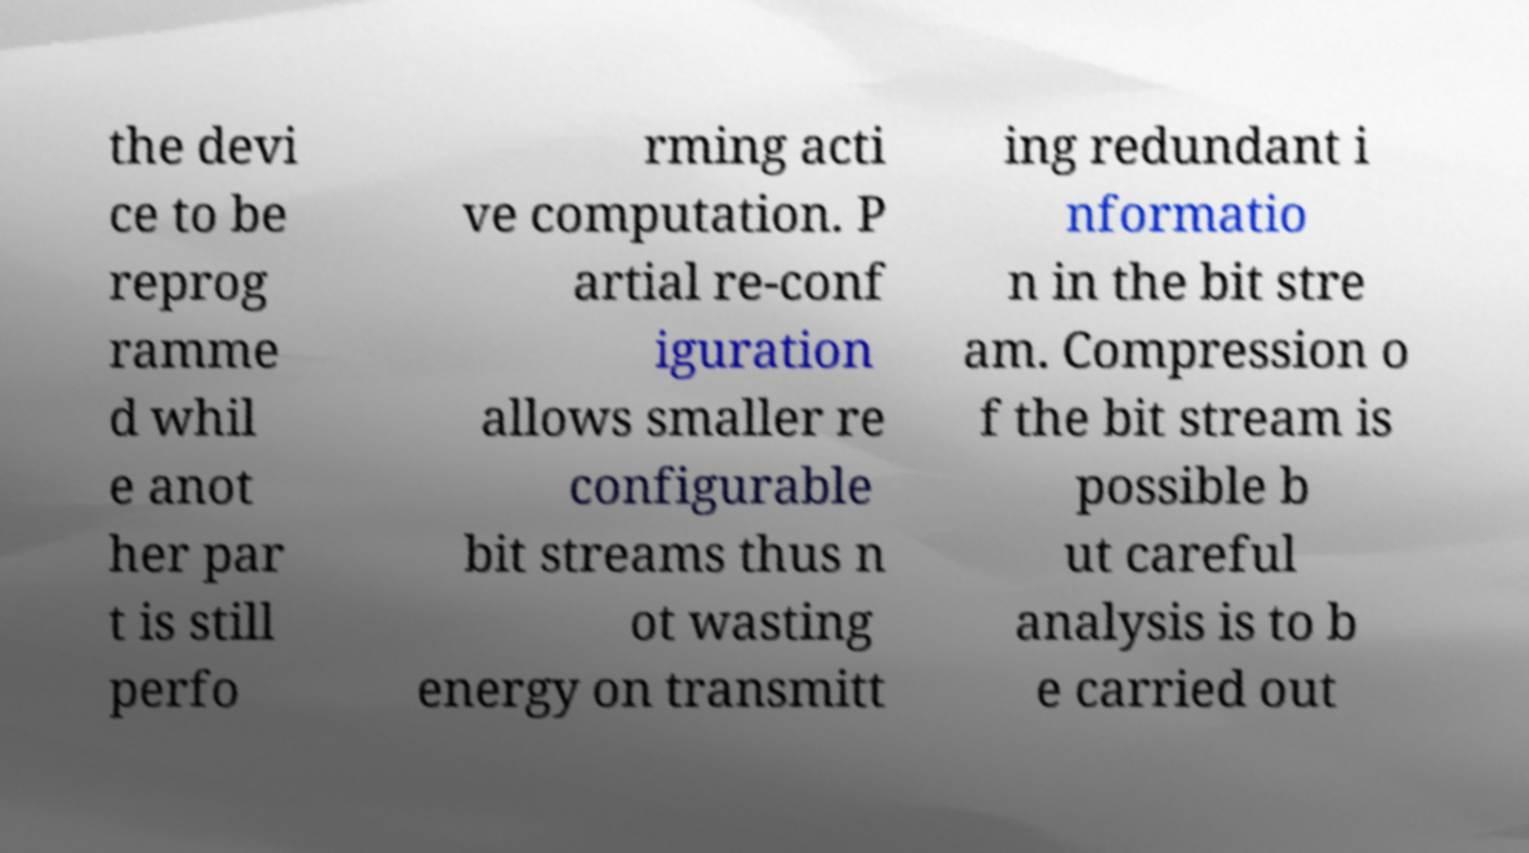What messages or text are displayed in this image? I need them in a readable, typed format. the devi ce to be reprog ramme d whil e anot her par t is still perfo rming acti ve computation. P artial re-conf iguration allows smaller re configurable bit streams thus n ot wasting energy on transmitt ing redundant i nformatio n in the bit stre am. Compression o f the bit stream is possible b ut careful analysis is to b e carried out 